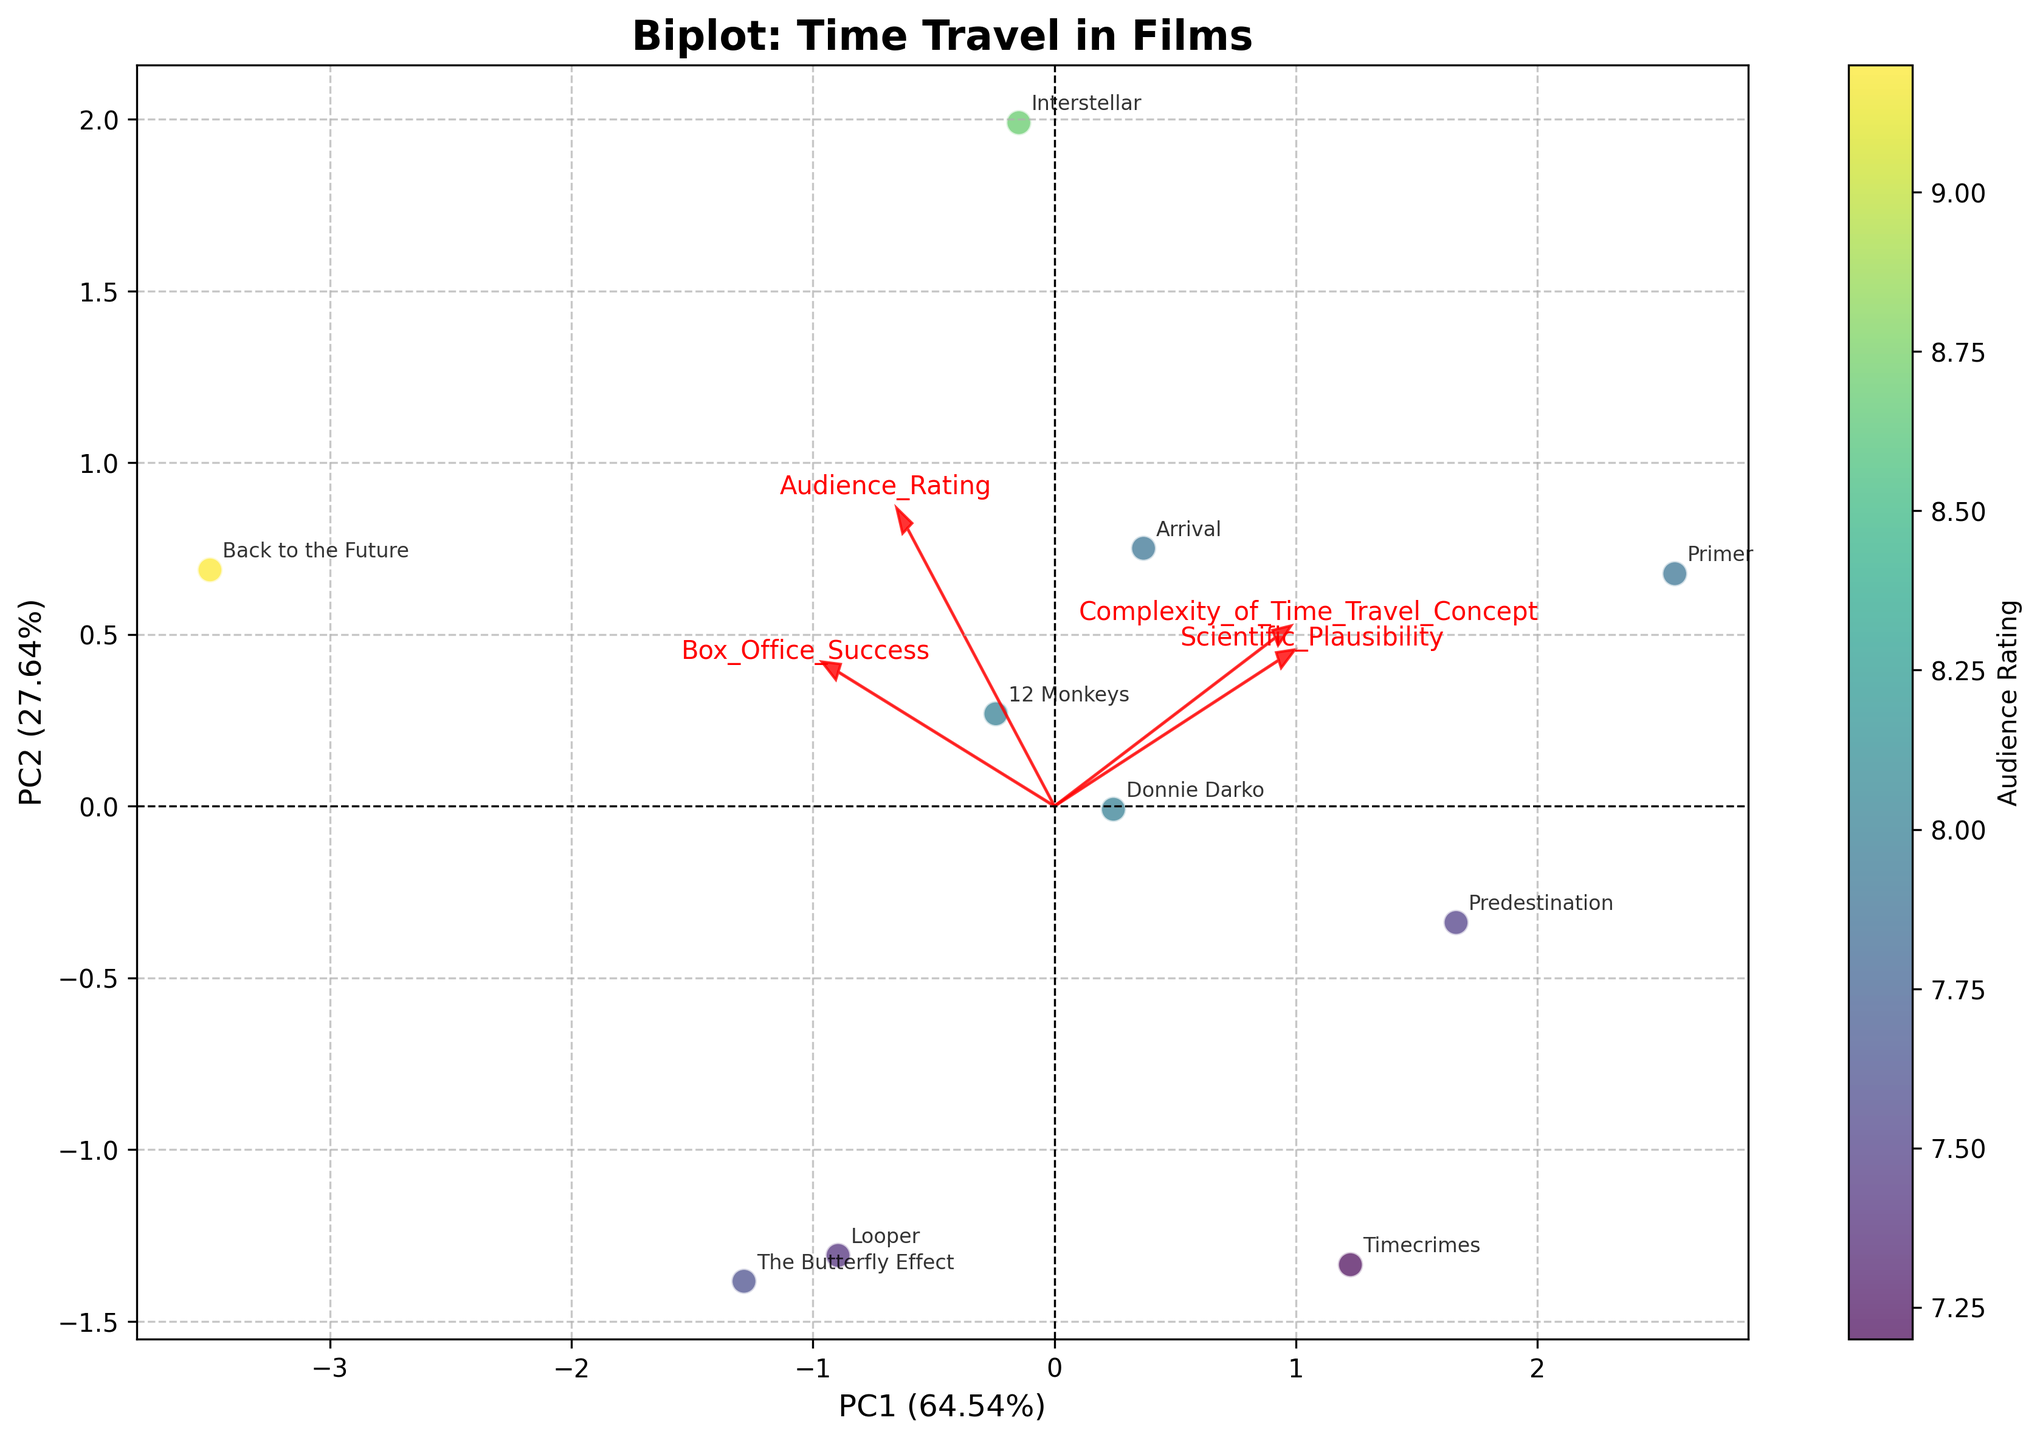What is the title of the plot? The plot has a prominent title at the top which reads, "Biplot: Time Travel in Films".
Answer: Biplot: Time Travel in Films How many films are analyzed in the plot? By counting the number of distinct data points labeled with movie titles, there are ten films being analyzed.
Answer: Ten Which axis represents the first principal component (PC1)? The x-axis is labeled as 'PC1' followed by the explained variance percentage, indicating it represents the first principal component.
Answer: x-axis Which film has the highest combined score for scientific plausibility and complexity of time travel concept based on the loading vectors? By observing the loading vectors, "Primer" appears to align highly with both the scientific plausibility and complexity vectors.
Answer: Primer How much variance does the first principal component explain? The x-axis label for PC1 indicates the percentage of variance explained. The label reads something like 'PC1 (XX.XX%)'.
Answer: ~XX.XX% Compare the audience ratings for "Interstellar" and "Back to the Future". Which one is higher? By looking at the color gradient of the data points, which represents the audience rating, "Back to the Future" has a more vibrant color indicating a higher rating than "Interstellar".
Answer: Back to the Future Which films are closely associated with high scientific plausibility? By following the direction of the loading vector for scientific plausibility, films like "Arrival", "Predestination", and "Primer" are closely aligned.
Answer: Arrival, Predestination, Primer What can be inferred about the relationship between box office success and audience rating? The loading vectors for these features point in similar directions, suggesting a positive correlation. This means higher audience ratings typically accompany higher box office success.
Answer: Positive correlation Is there any film that has a relatively high complexity of time travel concept but low box office success? "Primer" stands out as it aligns closely with the loading vector for the complexity of time travel concept while having a lower score along the box office success vector.
Answer: Primer 